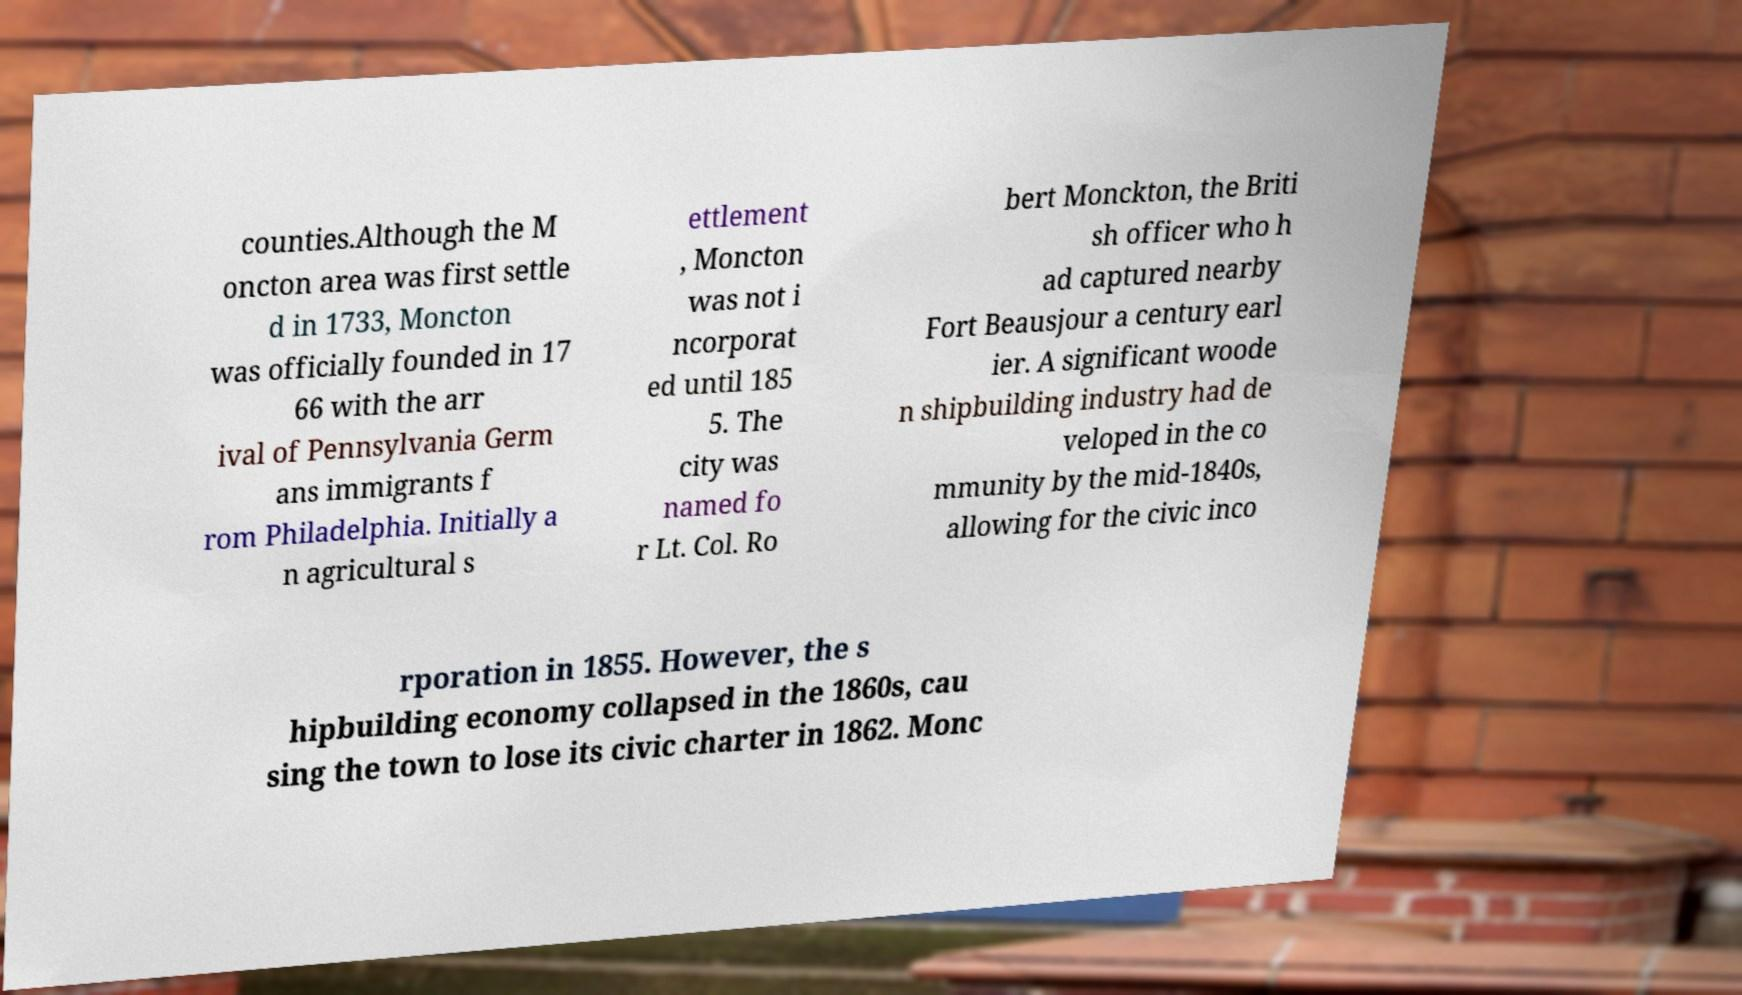There's text embedded in this image that I need extracted. Can you transcribe it verbatim? counties.Although the M oncton area was first settle d in 1733, Moncton was officially founded in 17 66 with the arr ival of Pennsylvania Germ ans immigrants f rom Philadelphia. Initially a n agricultural s ettlement , Moncton was not i ncorporat ed until 185 5. The city was named fo r Lt. Col. Ro bert Monckton, the Briti sh officer who h ad captured nearby Fort Beausjour a century earl ier. A significant woode n shipbuilding industry had de veloped in the co mmunity by the mid-1840s, allowing for the civic inco rporation in 1855. However, the s hipbuilding economy collapsed in the 1860s, cau sing the town to lose its civic charter in 1862. Monc 